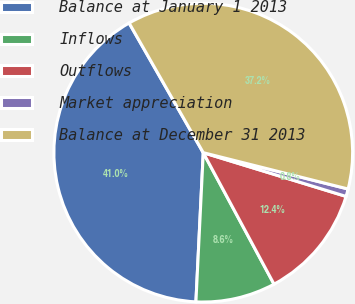<chart> <loc_0><loc_0><loc_500><loc_500><pie_chart><fcel>Balance at January 1 2013<fcel>Inflows<fcel>Outflows<fcel>Market appreciation<fcel>Balance at December 31 2013<nl><fcel>40.95%<fcel>8.64%<fcel>12.41%<fcel>0.82%<fcel>37.18%<nl></chart> 